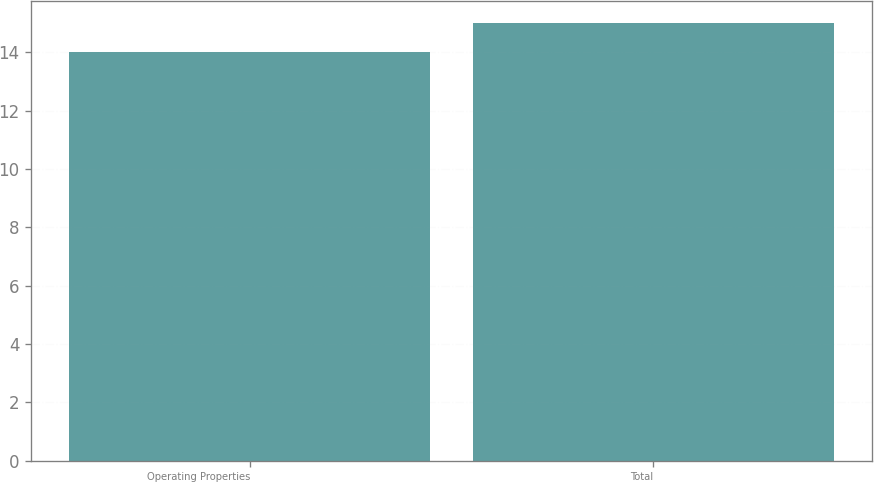Convert chart. <chart><loc_0><loc_0><loc_500><loc_500><bar_chart><fcel>Operating Properties<fcel>Total<nl><fcel>14<fcel>15<nl></chart> 